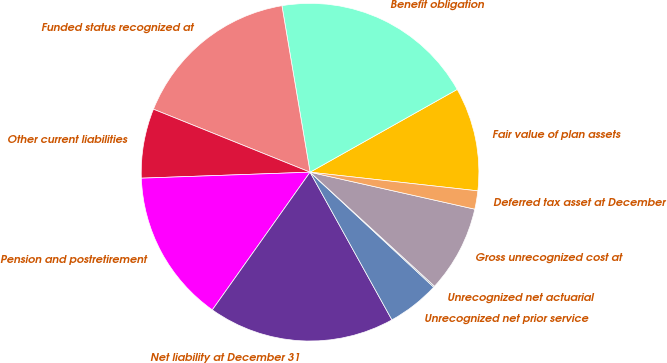<chart> <loc_0><loc_0><loc_500><loc_500><pie_chart><fcel>Fair value of plan assets<fcel>Benefit obligation<fcel>Funded status recognized at<fcel>Other current liabilities<fcel>Pension and postretirement<fcel>Net liability at December 31<fcel>Unrecognized net prior service<fcel>Unrecognized net actuarial<fcel>Gross unrecognized cost at<fcel>Deferred tax asset at December<nl><fcel>9.92%<fcel>19.51%<fcel>16.25%<fcel>6.65%<fcel>14.61%<fcel>17.88%<fcel>5.02%<fcel>0.12%<fcel>8.29%<fcel>1.75%<nl></chart> 